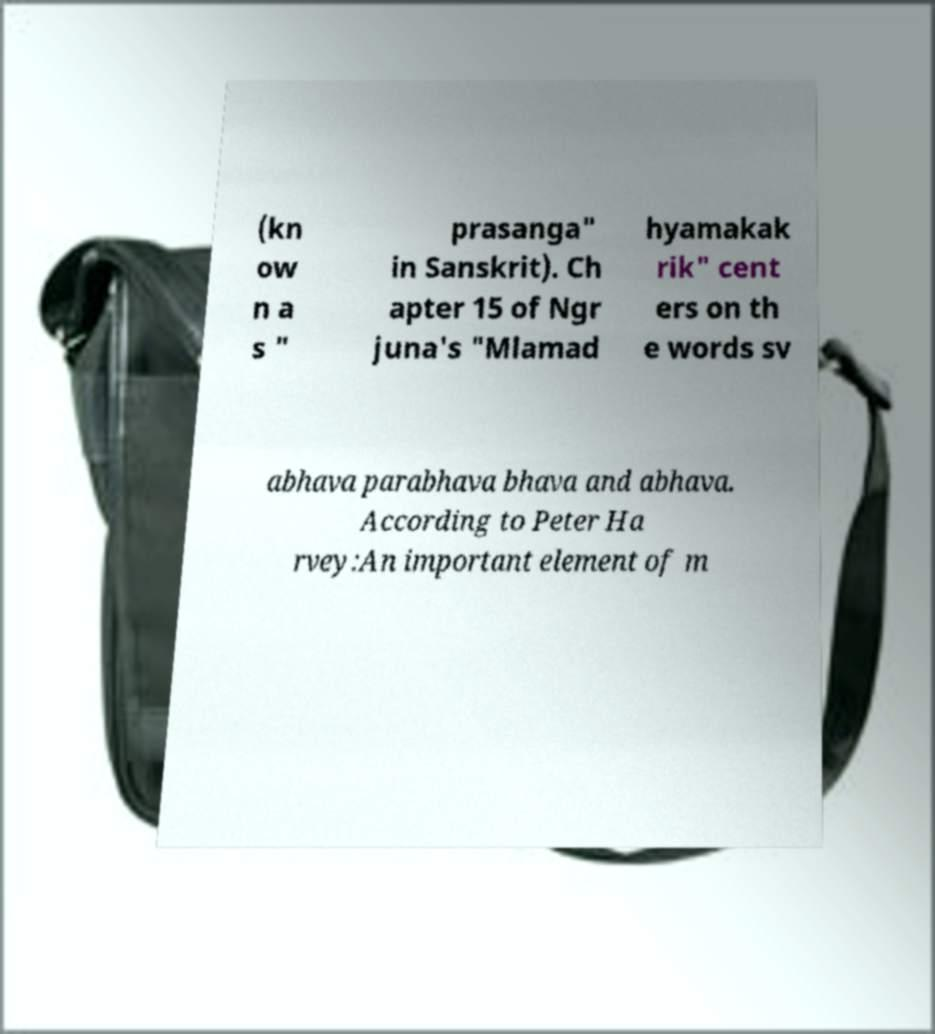I need the written content from this picture converted into text. Can you do that? (kn ow n a s " prasanga" in Sanskrit). Ch apter 15 of Ngr juna's "Mlamad hyamakak rik" cent ers on th e words sv abhava parabhava bhava and abhava. According to Peter Ha rvey:An important element of m 